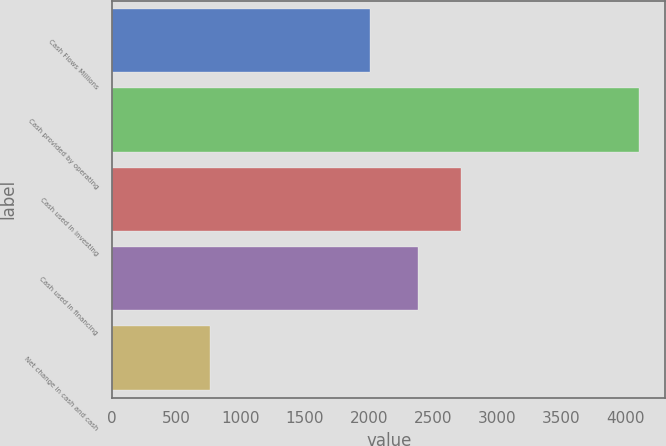<chart> <loc_0><loc_0><loc_500><loc_500><bar_chart><fcel>Cash Flows Millions<fcel>Cash provided by operating<fcel>Cash used in investing<fcel>Cash used in financing<fcel>Net change in cash and cash<nl><fcel>2010<fcel>4105<fcel>2715.1<fcel>2381<fcel>764<nl></chart> 